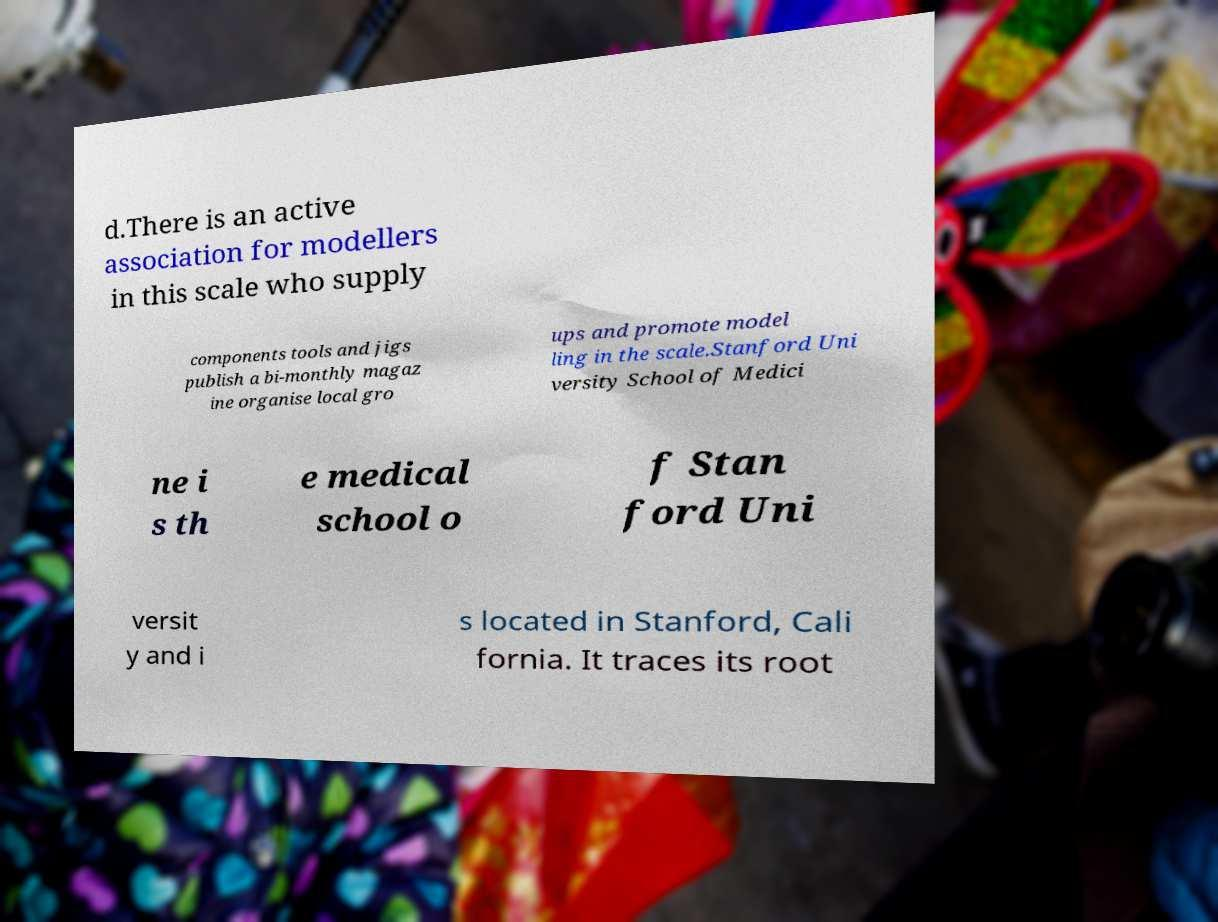I need the written content from this picture converted into text. Can you do that? d.There is an active association for modellers in this scale who supply components tools and jigs publish a bi-monthly magaz ine organise local gro ups and promote model ling in the scale.Stanford Uni versity School of Medici ne i s th e medical school o f Stan ford Uni versit y and i s located in Stanford, Cali fornia. It traces its root 